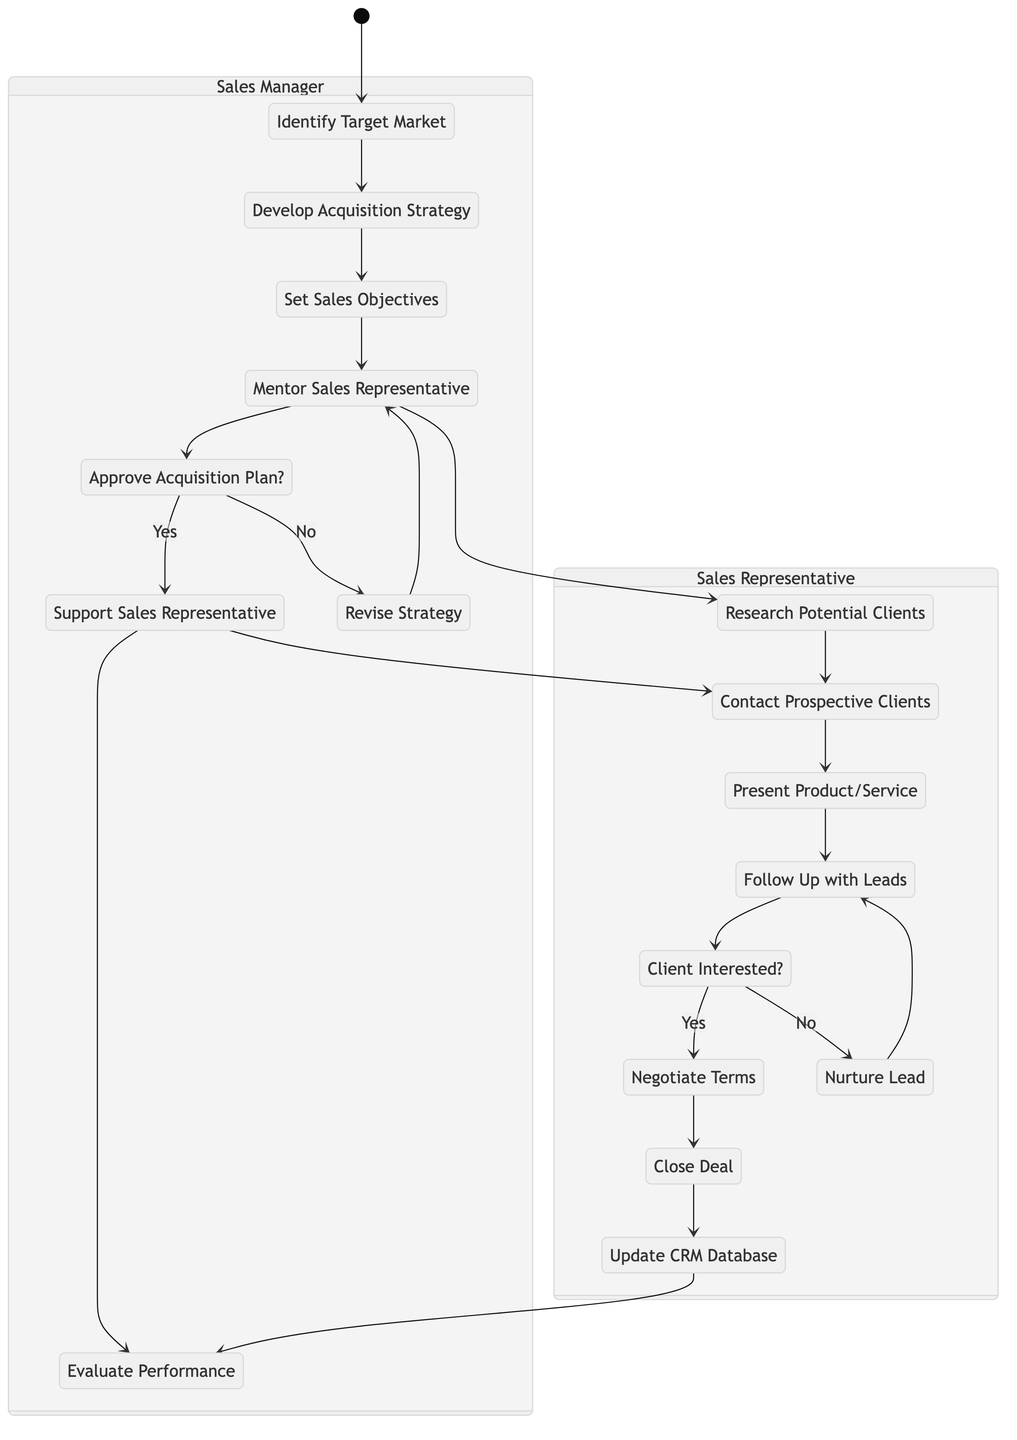What is the first action taken by the Sales Manager? The first action the Sales Manager takes is to "Identify Target Market," which is the initial node in their swimlane.
Answer: Identify Target Market How many decision nodes are present in the diagram? There are two decision nodes: "Approve Acquisition Plan?" in the Sales Manager swimlane and "Client Interested?" in the Sales Representative swimlane.
Answer: 2 What is the output if the Sales Manager approves the acquisition plan? If the Sales Manager approves the acquisition plan with a 'Yes', the next action is "Support Sales Representative," which follows the approval decision.
Answer: Support Sales Representative After closing a deal, which action comes next for the Sales Representative? The action that follows "Close Deal" for the Sales Representative is "Update CRM Database."
Answer: Update CRM Database What action follows after the Sales Manager mentors the Sales Representative? After the Sales Manager mentors the Sales Representative, the next activity is "Research Potential Clients," which is initiated by the Sales Representative.
Answer: Research Potential Clients If the client is not interested, what action does the Sales Representative take next? If the client is not interested, the Sales Representative will "Nurture Lead," which allows them to maintain engagement with the potential client.
Answer: Nurture Lead What is the final action in the Sales Manager's workflow? The last action in the Sales Manager's workflow is "Evaluate Performance," which assesses how well the previous activities were executed after supporting the Sales Representative.
Answer: Evaluate Performance What two actions are taken by the Sales Manager if the acquisition plan is not approved? If the acquisition plan is not approved, the Sales Manager will first "Revise Strategy" and then return to "Mentor Sales Representative."
Answer: Revise Strategy, Mentor Sales Representative 